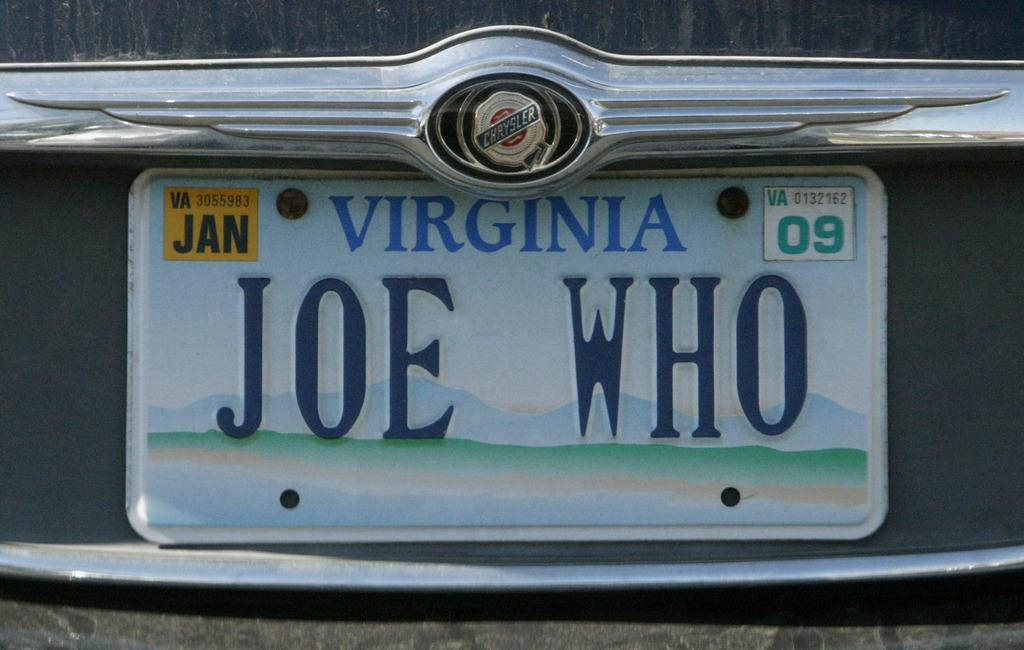Provide a one-sentence caption for the provided image. Joe Who is a driver who is licensded in Virginia. 